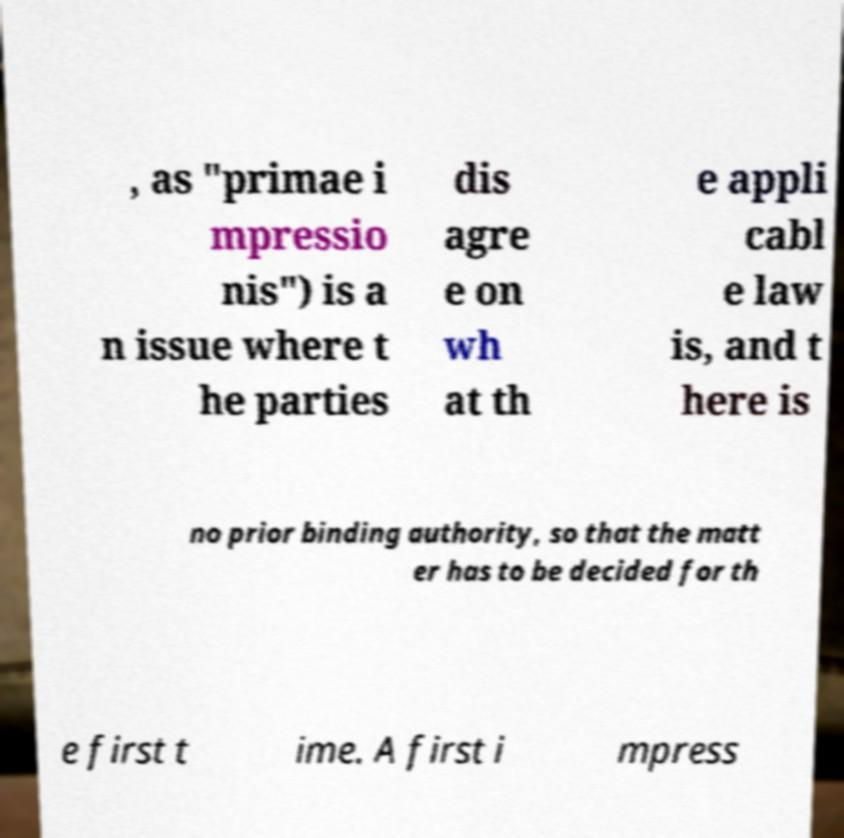Could you extract and type out the text from this image? , as "primae i mpressio nis") is a n issue where t he parties dis agre e on wh at th e appli cabl e law is, and t here is no prior binding authority, so that the matt er has to be decided for th e first t ime. A first i mpress 